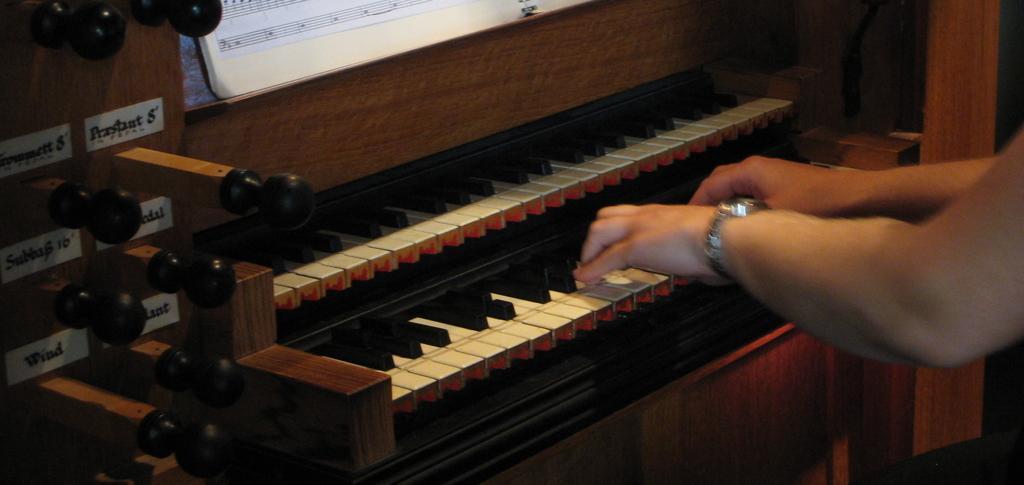Please provide a concise description of this image. In this image I see a person's hand on the piano and I see a book. 